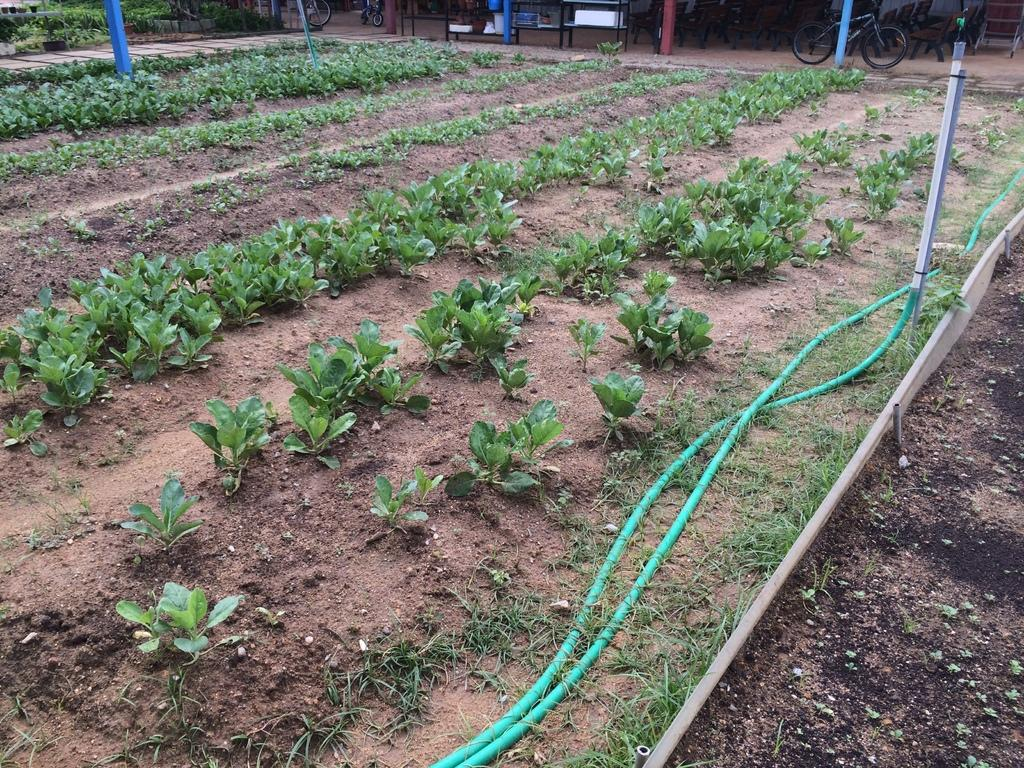What type of vegetation is present on the ground in the image? There are plants on the ground in the image. What type of infrastructure can be seen in the image? There are pipes visible in the image. What type of transportation is present in the image? There are vehicles in the image. What type of furniture is present in the image? There are tables in the image. Is there any snow visible in the image? There is no snow present in the image. Is there any blood visible in the image? There is no blood present in the image. 